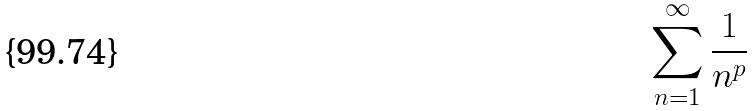<formula> <loc_0><loc_0><loc_500><loc_500>\sum _ { n = 1 } ^ { \infty } \frac { 1 } { n ^ { p } }</formula> 